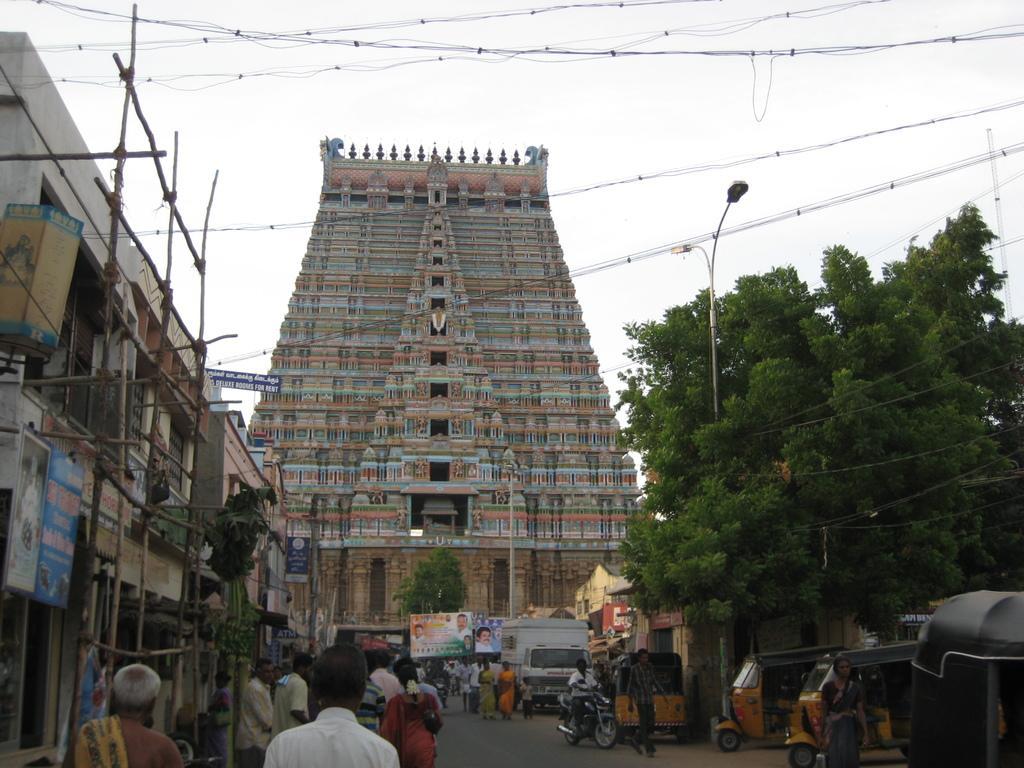How would you summarize this image in a sentence or two? In the picture I can see buildings, trees and vehicles on the road. I can also see people walking on the ground, wires, street lights and some other objects. In the background I can see the sky. 